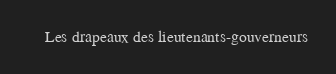Convert code to text. <code><loc_0><loc_0><loc_500><loc_500><_XML_>	 Les drapeaux des lieutenants-gouverneurs 
</code> 